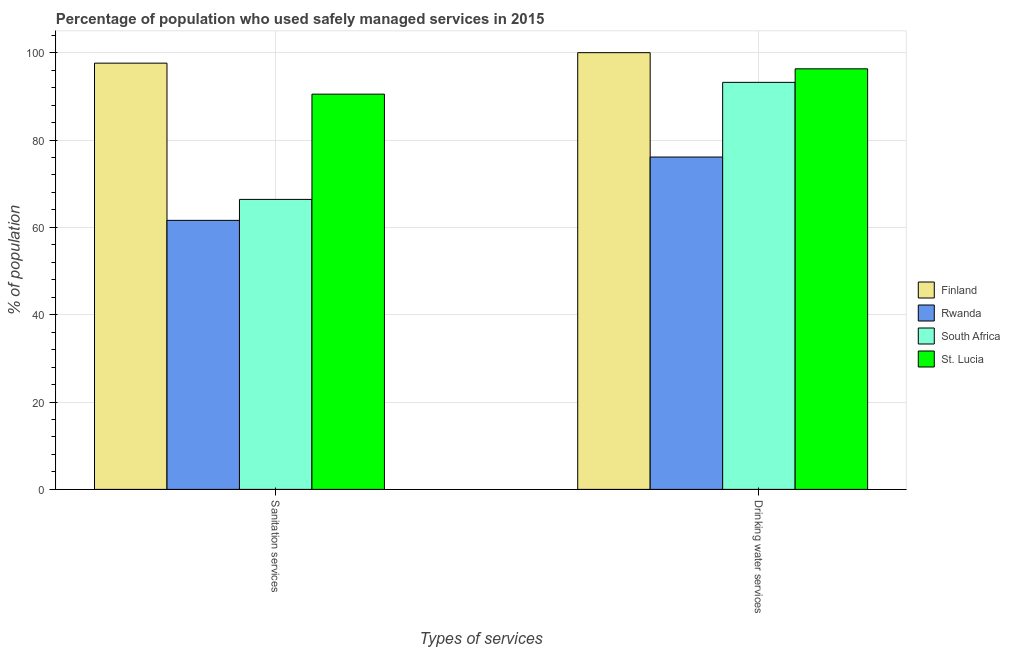How many different coloured bars are there?
Offer a very short reply. 4. How many groups of bars are there?
Provide a short and direct response. 2. Are the number of bars per tick equal to the number of legend labels?
Provide a succinct answer. Yes. How many bars are there on the 2nd tick from the left?
Make the answer very short. 4. What is the label of the 2nd group of bars from the left?
Your response must be concise. Drinking water services. What is the percentage of population who used sanitation services in St. Lucia?
Keep it short and to the point. 90.5. Across all countries, what is the maximum percentage of population who used sanitation services?
Give a very brief answer. 97.6. Across all countries, what is the minimum percentage of population who used drinking water services?
Offer a terse response. 76.1. In which country was the percentage of population who used drinking water services minimum?
Your response must be concise. Rwanda. What is the total percentage of population who used drinking water services in the graph?
Offer a very short reply. 365.6. What is the difference between the percentage of population who used drinking water services in Rwanda and that in Finland?
Make the answer very short. -23.9. What is the difference between the percentage of population who used drinking water services in Rwanda and the percentage of population who used sanitation services in South Africa?
Your response must be concise. 9.7. What is the average percentage of population who used drinking water services per country?
Offer a very short reply. 91.4. What is the difference between the percentage of population who used sanitation services and percentage of population who used drinking water services in St. Lucia?
Keep it short and to the point. -5.8. What is the ratio of the percentage of population who used sanitation services in Finland to that in South Africa?
Give a very brief answer. 1.47. Is the percentage of population who used drinking water services in St. Lucia less than that in South Africa?
Keep it short and to the point. No. What does the 2nd bar from the left in Drinking water services represents?
Offer a very short reply. Rwanda. Are the values on the major ticks of Y-axis written in scientific E-notation?
Ensure brevity in your answer.  No. Does the graph contain grids?
Provide a succinct answer. Yes. How many legend labels are there?
Offer a terse response. 4. How are the legend labels stacked?
Your answer should be very brief. Vertical. What is the title of the graph?
Provide a succinct answer. Percentage of population who used safely managed services in 2015. Does "Fiji" appear as one of the legend labels in the graph?
Make the answer very short. No. What is the label or title of the X-axis?
Offer a terse response. Types of services. What is the label or title of the Y-axis?
Your answer should be compact. % of population. What is the % of population in Finland in Sanitation services?
Your response must be concise. 97.6. What is the % of population in Rwanda in Sanitation services?
Offer a very short reply. 61.6. What is the % of population of South Africa in Sanitation services?
Provide a succinct answer. 66.4. What is the % of population in St. Lucia in Sanitation services?
Your response must be concise. 90.5. What is the % of population in Finland in Drinking water services?
Offer a very short reply. 100. What is the % of population in Rwanda in Drinking water services?
Provide a succinct answer. 76.1. What is the % of population of South Africa in Drinking water services?
Make the answer very short. 93.2. What is the % of population of St. Lucia in Drinking water services?
Offer a terse response. 96.3. Across all Types of services, what is the maximum % of population of Finland?
Make the answer very short. 100. Across all Types of services, what is the maximum % of population in Rwanda?
Give a very brief answer. 76.1. Across all Types of services, what is the maximum % of population in South Africa?
Keep it short and to the point. 93.2. Across all Types of services, what is the maximum % of population of St. Lucia?
Offer a terse response. 96.3. Across all Types of services, what is the minimum % of population in Finland?
Give a very brief answer. 97.6. Across all Types of services, what is the minimum % of population in Rwanda?
Offer a terse response. 61.6. Across all Types of services, what is the minimum % of population in South Africa?
Offer a terse response. 66.4. Across all Types of services, what is the minimum % of population in St. Lucia?
Offer a very short reply. 90.5. What is the total % of population of Finland in the graph?
Offer a very short reply. 197.6. What is the total % of population in Rwanda in the graph?
Your answer should be compact. 137.7. What is the total % of population of South Africa in the graph?
Make the answer very short. 159.6. What is the total % of population of St. Lucia in the graph?
Your response must be concise. 186.8. What is the difference between the % of population in Rwanda in Sanitation services and that in Drinking water services?
Give a very brief answer. -14.5. What is the difference between the % of population of South Africa in Sanitation services and that in Drinking water services?
Your answer should be compact. -26.8. What is the difference between the % of population of St. Lucia in Sanitation services and that in Drinking water services?
Your response must be concise. -5.8. What is the difference between the % of population in Finland in Sanitation services and the % of population in St. Lucia in Drinking water services?
Your response must be concise. 1.3. What is the difference between the % of population of Rwanda in Sanitation services and the % of population of South Africa in Drinking water services?
Ensure brevity in your answer.  -31.6. What is the difference between the % of population of Rwanda in Sanitation services and the % of population of St. Lucia in Drinking water services?
Your answer should be compact. -34.7. What is the difference between the % of population of South Africa in Sanitation services and the % of population of St. Lucia in Drinking water services?
Offer a terse response. -29.9. What is the average % of population in Finland per Types of services?
Make the answer very short. 98.8. What is the average % of population of Rwanda per Types of services?
Your answer should be very brief. 68.85. What is the average % of population of South Africa per Types of services?
Provide a succinct answer. 79.8. What is the average % of population in St. Lucia per Types of services?
Your answer should be compact. 93.4. What is the difference between the % of population of Finland and % of population of Rwanda in Sanitation services?
Provide a succinct answer. 36. What is the difference between the % of population of Finland and % of population of South Africa in Sanitation services?
Your answer should be very brief. 31.2. What is the difference between the % of population in Finland and % of population in St. Lucia in Sanitation services?
Ensure brevity in your answer.  7.1. What is the difference between the % of population of Rwanda and % of population of South Africa in Sanitation services?
Your response must be concise. -4.8. What is the difference between the % of population of Rwanda and % of population of St. Lucia in Sanitation services?
Your answer should be very brief. -28.9. What is the difference between the % of population in South Africa and % of population in St. Lucia in Sanitation services?
Keep it short and to the point. -24.1. What is the difference between the % of population of Finland and % of population of Rwanda in Drinking water services?
Your response must be concise. 23.9. What is the difference between the % of population of Finland and % of population of South Africa in Drinking water services?
Your answer should be very brief. 6.8. What is the difference between the % of population of Finland and % of population of St. Lucia in Drinking water services?
Make the answer very short. 3.7. What is the difference between the % of population of Rwanda and % of population of South Africa in Drinking water services?
Your answer should be compact. -17.1. What is the difference between the % of population of Rwanda and % of population of St. Lucia in Drinking water services?
Make the answer very short. -20.2. What is the ratio of the % of population in Finland in Sanitation services to that in Drinking water services?
Ensure brevity in your answer.  0.98. What is the ratio of the % of population of Rwanda in Sanitation services to that in Drinking water services?
Your answer should be very brief. 0.81. What is the ratio of the % of population of South Africa in Sanitation services to that in Drinking water services?
Give a very brief answer. 0.71. What is the ratio of the % of population of St. Lucia in Sanitation services to that in Drinking water services?
Your answer should be compact. 0.94. What is the difference between the highest and the second highest % of population of Finland?
Your answer should be very brief. 2.4. What is the difference between the highest and the second highest % of population in South Africa?
Your response must be concise. 26.8. What is the difference between the highest and the second highest % of population in St. Lucia?
Ensure brevity in your answer.  5.8. What is the difference between the highest and the lowest % of population of Finland?
Offer a terse response. 2.4. What is the difference between the highest and the lowest % of population in South Africa?
Provide a short and direct response. 26.8. 